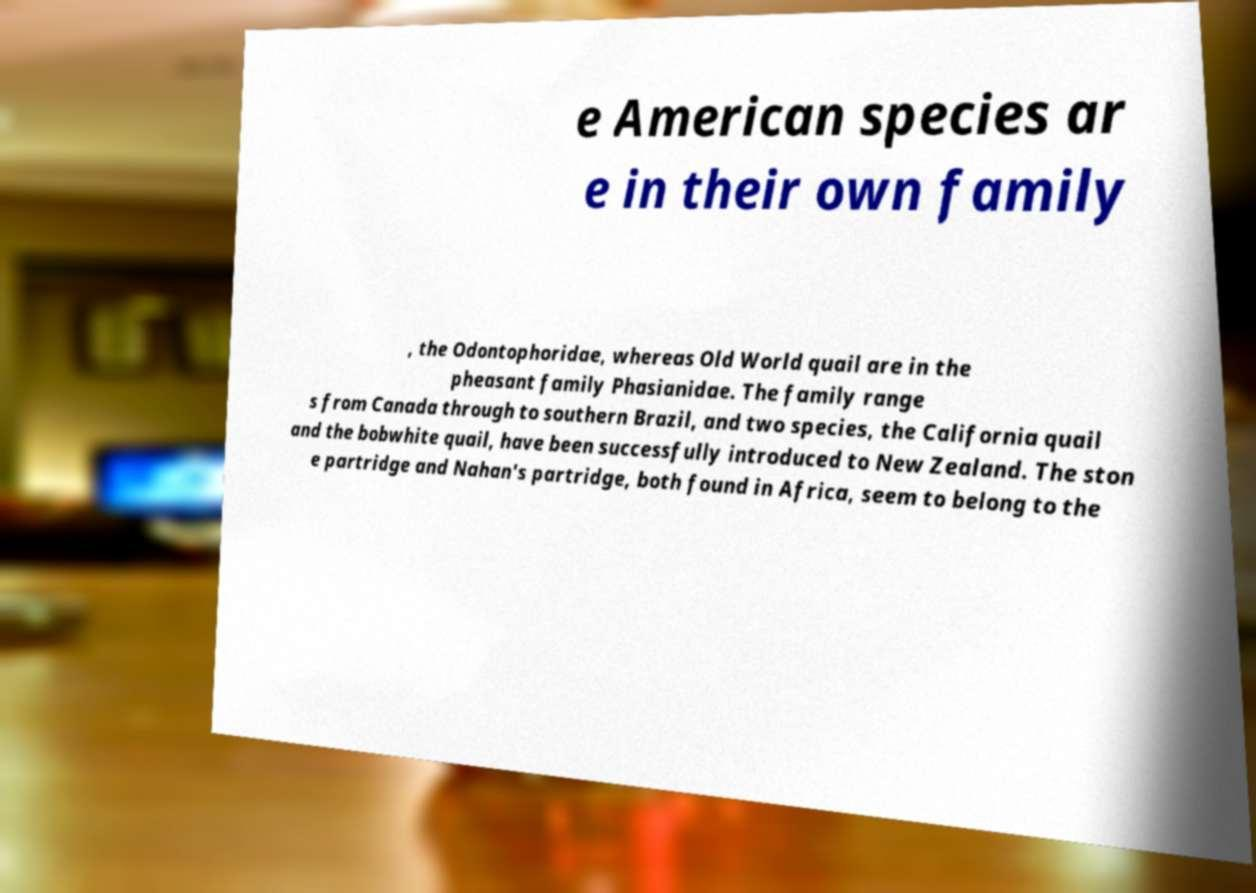What messages or text are displayed in this image? I need them in a readable, typed format. e American species ar e in their own family , the Odontophoridae, whereas Old World quail are in the pheasant family Phasianidae. The family range s from Canada through to southern Brazil, and two species, the California quail and the bobwhite quail, have been successfully introduced to New Zealand. The ston e partridge and Nahan's partridge, both found in Africa, seem to belong to the 